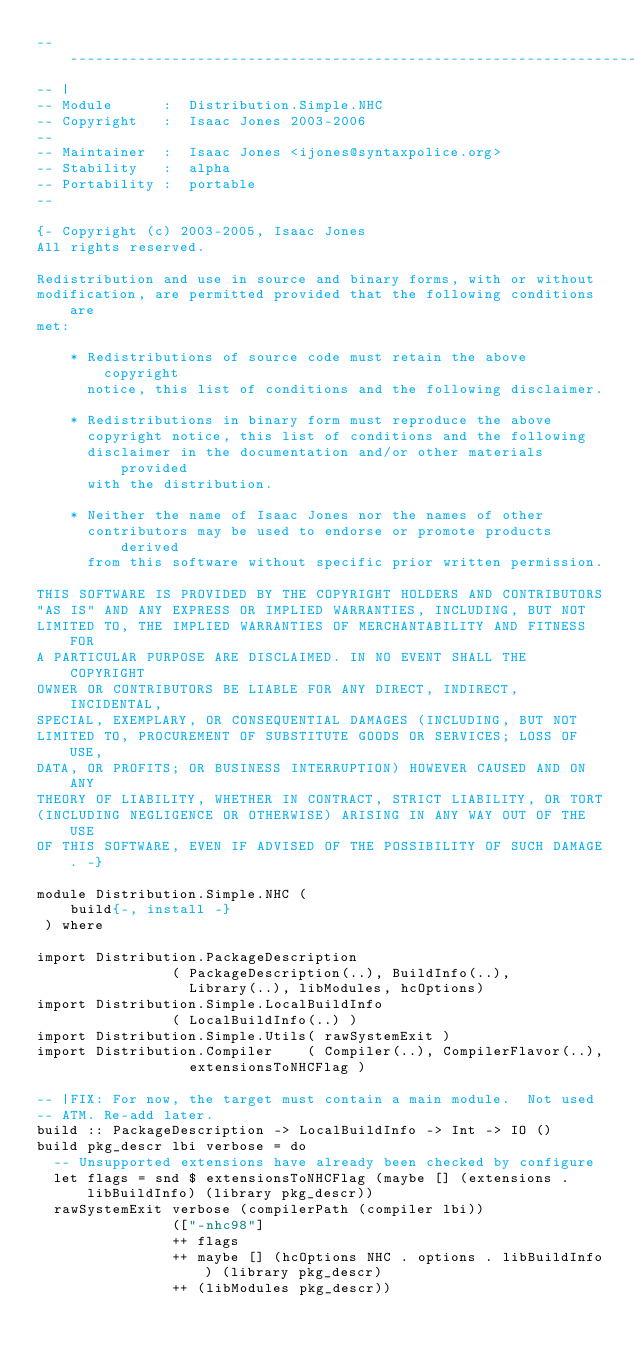<code> <loc_0><loc_0><loc_500><loc_500><_Haskell_>-----------------------------------------------------------------------------
-- |
-- Module      :  Distribution.Simple.NHC
-- Copyright   :  Isaac Jones 2003-2006
-- 
-- Maintainer  :  Isaac Jones <ijones@syntaxpolice.org>
-- Stability   :  alpha
-- Portability :  portable
--

{- Copyright (c) 2003-2005, Isaac Jones
All rights reserved.

Redistribution and use in source and binary forms, with or without
modification, are permitted provided that the following conditions are
met:

    * Redistributions of source code must retain the above copyright
      notice, this list of conditions and the following disclaimer.

    * Redistributions in binary form must reproduce the above
      copyright notice, this list of conditions and the following
      disclaimer in the documentation and/or other materials provided
      with the distribution.

    * Neither the name of Isaac Jones nor the names of other
      contributors may be used to endorse or promote products derived
      from this software without specific prior written permission.

THIS SOFTWARE IS PROVIDED BY THE COPYRIGHT HOLDERS AND CONTRIBUTORS
"AS IS" AND ANY EXPRESS OR IMPLIED WARRANTIES, INCLUDING, BUT NOT
LIMITED TO, THE IMPLIED WARRANTIES OF MERCHANTABILITY AND FITNESS FOR
A PARTICULAR PURPOSE ARE DISCLAIMED. IN NO EVENT SHALL THE COPYRIGHT
OWNER OR CONTRIBUTORS BE LIABLE FOR ANY DIRECT, INDIRECT, INCIDENTAL,
SPECIAL, EXEMPLARY, OR CONSEQUENTIAL DAMAGES (INCLUDING, BUT NOT
LIMITED TO, PROCUREMENT OF SUBSTITUTE GOODS OR SERVICES; LOSS OF USE,
DATA, OR PROFITS; OR BUSINESS INTERRUPTION) HOWEVER CAUSED AND ON ANY
THEORY OF LIABILITY, WHETHER IN CONTRACT, STRICT LIABILITY, OR TORT
(INCLUDING NEGLIGENCE OR OTHERWISE) ARISING IN ANY WAY OUT OF THE USE
OF THIS SOFTWARE, EVEN IF ADVISED OF THE POSSIBILITY OF SUCH DAMAGE. -}

module Distribution.Simple.NHC (
	build{-, install -}
 ) where

import Distribution.PackageDescription
				( PackageDescription(..), BuildInfo(..),
				  Library(..), libModules, hcOptions)
import Distribution.Simple.LocalBuildInfo
				( LocalBuildInfo(..) )
import Distribution.Simple.Utils( rawSystemExit )
import Distribution.Compiler 	( Compiler(..), CompilerFlavor(..),
				  extensionsToNHCFlag )

-- |FIX: For now, the target must contain a main module.  Not used
-- ATM. Re-add later.
build :: PackageDescription -> LocalBuildInfo -> Int -> IO ()
build pkg_descr lbi verbose = do
  -- Unsupported extensions have already been checked by configure
  let flags = snd $ extensionsToNHCFlag (maybe [] (extensions . libBuildInfo) (library pkg_descr))
  rawSystemExit verbose (compilerPath (compiler lbi))
                (["-nhc98"]
                ++ flags
                ++ maybe [] (hcOptions NHC . options . libBuildInfo) (library pkg_descr)
                ++ (libModules pkg_descr))

</code> 